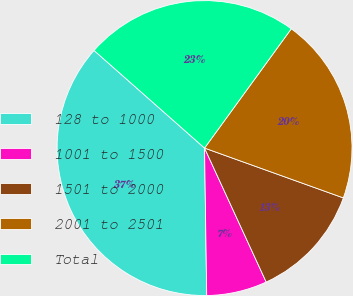Convert chart. <chart><loc_0><loc_0><loc_500><loc_500><pie_chart><fcel>128 to 1000<fcel>1001 to 1500<fcel>1501 to 2000<fcel>2001 to 2501<fcel>Total<nl><fcel>36.75%<fcel>6.63%<fcel>12.65%<fcel>20.48%<fcel>23.49%<nl></chart> 